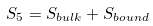<formula> <loc_0><loc_0><loc_500><loc_500>S _ { 5 } = S _ { b u l k } + S _ { b o u n d }</formula> 